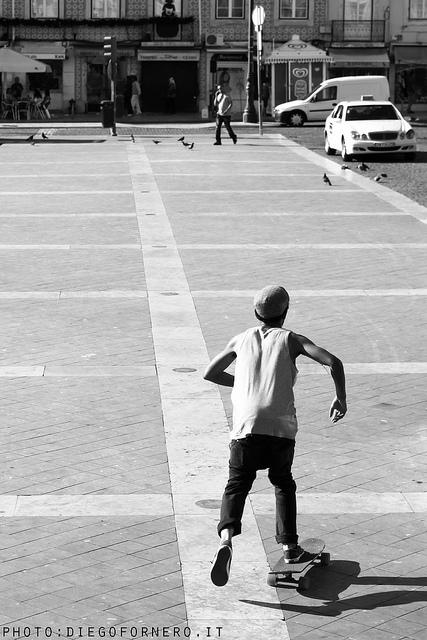What kind of refined natural resource is used to power the white car? gasoline 